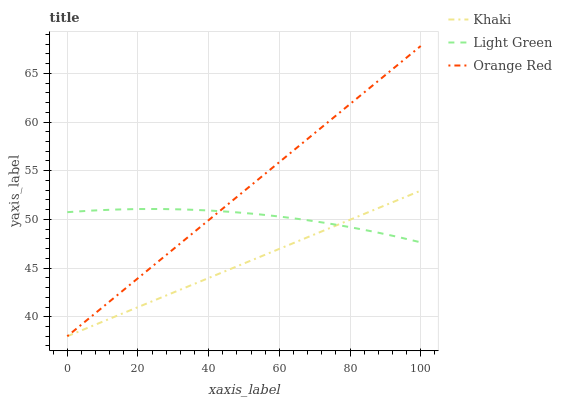Does Khaki have the minimum area under the curve?
Answer yes or no. Yes. Does Orange Red have the maximum area under the curve?
Answer yes or no. Yes. Does Light Green have the minimum area under the curve?
Answer yes or no. No. Does Light Green have the maximum area under the curve?
Answer yes or no. No. Is Khaki the smoothest?
Answer yes or no. Yes. Is Light Green the roughest?
Answer yes or no. Yes. Is Orange Red the smoothest?
Answer yes or no. No. Is Orange Red the roughest?
Answer yes or no. No. Does Khaki have the lowest value?
Answer yes or no. Yes. Does Light Green have the lowest value?
Answer yes or no. No. Does Orange Red have the highest value?
Answer yes or no. Yes. Does Light Green have the highest value?
Answer yes or no. No. Does Khaki intersect Light Green?
Answer yes or no. Yes. Is Khaki less than Light Green?
Answer yes or no. No. Is Khaki greater than Light Green?
Answer yes or no. No. 